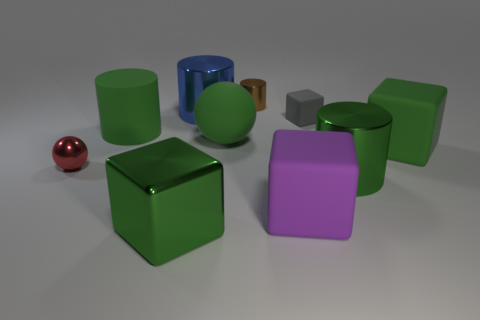Subtract all cylinders. How many objects are left? 6 Add 1 tiny objects. How many tiny objects exist? 4 Subtract 1 purple blocks. How many objects are left? 9 Subtract all gray matte blocks. Subtract all tiny blocks. How many objects are left? 8 Add 8 green cubes. How many green cubes are left? 10 